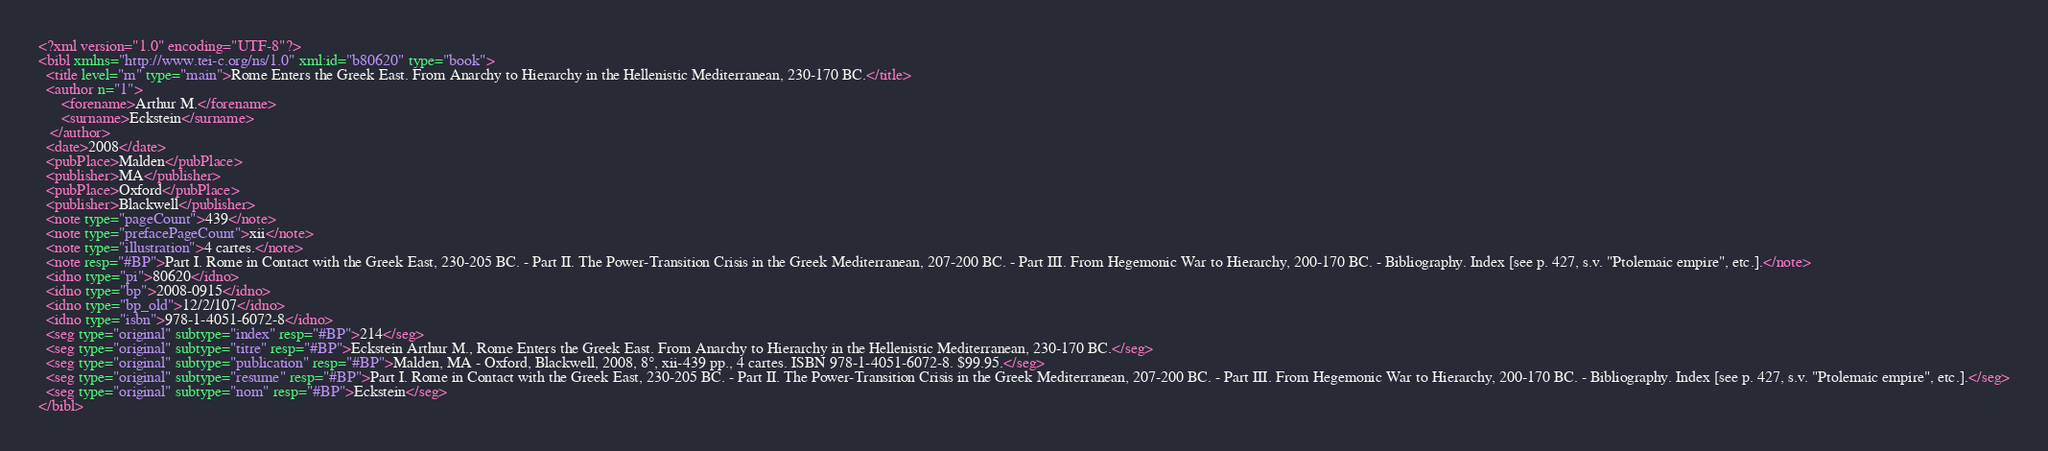<code> <loc_0><loc_0><loc_500><loc_500><_XML_><?xml version="1.0" encoding="UTF-8"?>
<bibl xmlns="http://www.tei-c.org/ns/1.0" xml:id="b80620" type="book">
  <title level="m" type="main">Rome Enters the Greek East. From Anarchy to Hierarchy in the Hellenistic Mediterranean, 230-170 BC.</title>
  <author n="1">
      <forename>Arthur M.</forename>
      <surname>Eckstein</surname>
   </author>
  <date>2008</date>
  <pubPlace>Malden</pubPlace>
  <publisher>MA</publisher>
  <pubPlace>Oxford</pubPlace>
  <publisher>Blackwell</publisher>
  <note type="pageCount">439</note>
  <note type="prefacePageCount">xii</note>
  <note type="illustration">4 cartes.</note>
  <note resp="#BP">Part I. Rome in Contact with the Greek East, 230-205 BC. - Part II. The Power-Transition Crisis in the Greek Mediterranean, 207-200 BC. - Part III. From Hegemonic War to Hierarchy, 200-170 BC. - Bibliography. Index [see p. 427, s.v. "Ptolemaic empire", etc.].</note>
  <idno type="pi">80620</idno>
  <idno type="bp">2008-0915</idno>
  <idno type="bp_old">12/2/107</idno>
  <idno type="isbn">978-1-4051-6072-8</idno>
  <seg type="original" subtype="index" resp="#BP">214</seg>
  <seg type="original" subtype="titre" resp="#BP">Eckstein Arthur M., Rome Enters the Greek East. From Anarchy to Hierarchy in the Hellenistic Mediterranean, 230-170 BC.</seg>
  <seg type="original" subtype="publication" resp="#BP">Malden, MA - Oxford, Blackwell, 2008, 8°, xii-439 pp., 4 cartes. ISBN 978-1-4051-6072-8. $99.95.</seg>
  <seg type="original" subtype="resume" resp="#BP">Part I. Rome in Contact with the Greek East, 230-205 BC. - Part II. The Power-Transition Crisis in the Greek Mediterranean, 207-200 BC. - Part III. From Hegemonic War to Hierarchy, 200-170 BC. - Bibliography. Index [see p. 427, s.v. "Ptolemaic empire", etc.].</seg>
  <seg type="original" subtype="nom" resp="#BP">Eckstein</seg>
</bibl>
</code> 